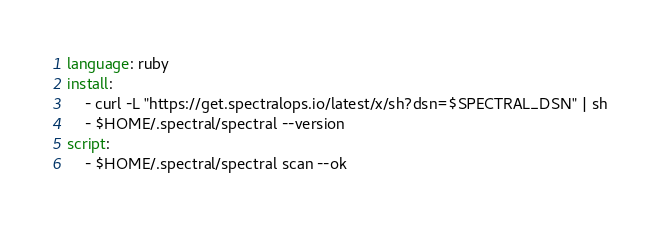<code> <loc_0><loc_0><loc_500><loc_500><_YAML_>language: ruby
install:
    - curl -L "https://get.spectralops.io/latest/x/sh?dsn=$SPECTRAL_DSN" | sh
    - $HOME/.spectral/spectral --version
script:
    - $HOME/.spectral/spectral scan --ok
</code> 